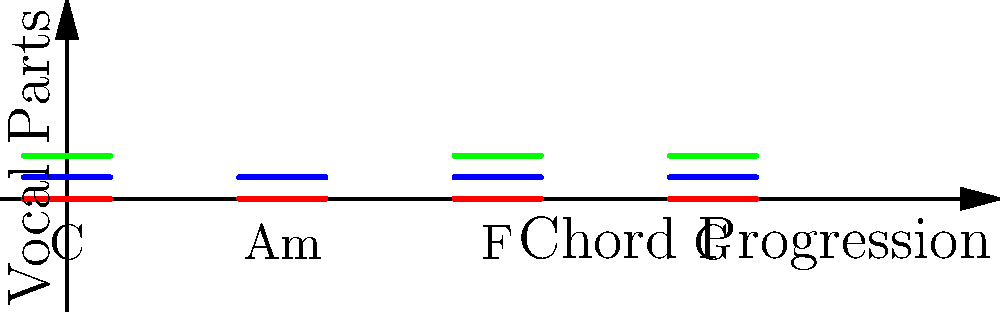In the chord progression chart above, which chord utilizes only two vocal parts instead of the full three-part harmony? To answer this question, we need to analyze the chord progression chart and identify the number of vocal parts used in each chord:

1. The chart shows a progression of four chords: C, Am, F, and G.
2. Each chord is represented by horizontal lines, with each line color corresponding to a different vocal part.
3. The legend on the left indicates:
   - Red line: Lead vocal
   - Blue line: Harmony 1
   - Green line: Harmony 2
4. Examining each chord:
   - C chord: Shows all three colors (red, blue, green)
   - Am chord: Shows only two colors (red and blue)
   - F chord: Shows all three colors (red, blue, green)
   - G chord: Shows all three colors (red, blue, green)
5. The Am chord is the only one with just two vocal parts (lead and harmony 1) instead of the full three-part harmony.

Therefore, the chord that utilizes only two vocal parts is Am (A minor).
Answer: Am 